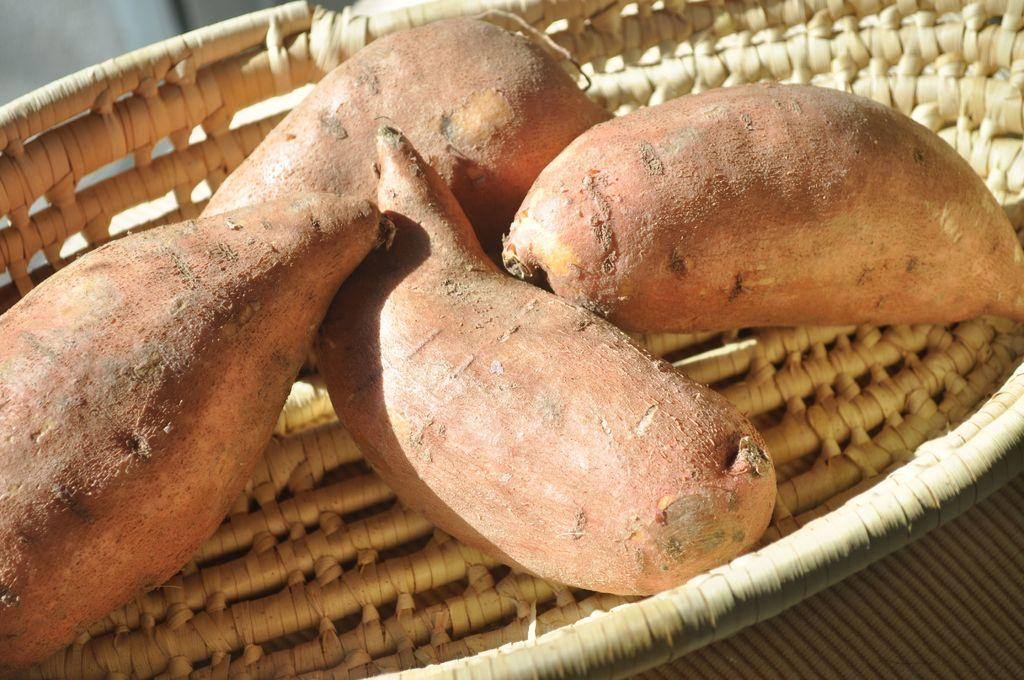What is the color of the basket in the image? The basket in the image is light brown in color. What is inside the basket? There are 4 sweet potatoes on the basket. Can you see a boy playing near the ocean in the image? There is no boy or ocean present in the image; it only features a light brown color basket with 4 sweet potatoes. 